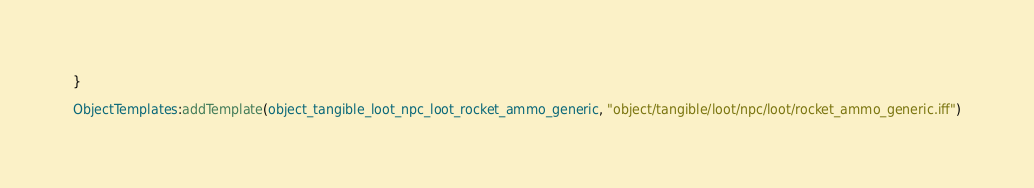Convert code to text. <code><loc_0><loc_0><loc_500><loc_500><_Lua_>
}

ObjectTemplates:addTemplate(object_tangible_loot_npc_loot_rocket_ammo_generic, "object/tangible/loot/npc/loot/rocket_ammo_generic.iff")
</code> 